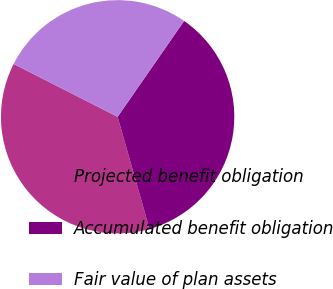Convert chart. <chart><loc_0><loc_0><loc_500><loc_500><pie_chart><fcel>Projected benefit obligation<fcel>Accumulated benefit obligation<fcel>Fair value of plan assets<nl><fcel>36.88%<fcel>35.94%<fcel>27.17%<nl></chart> 